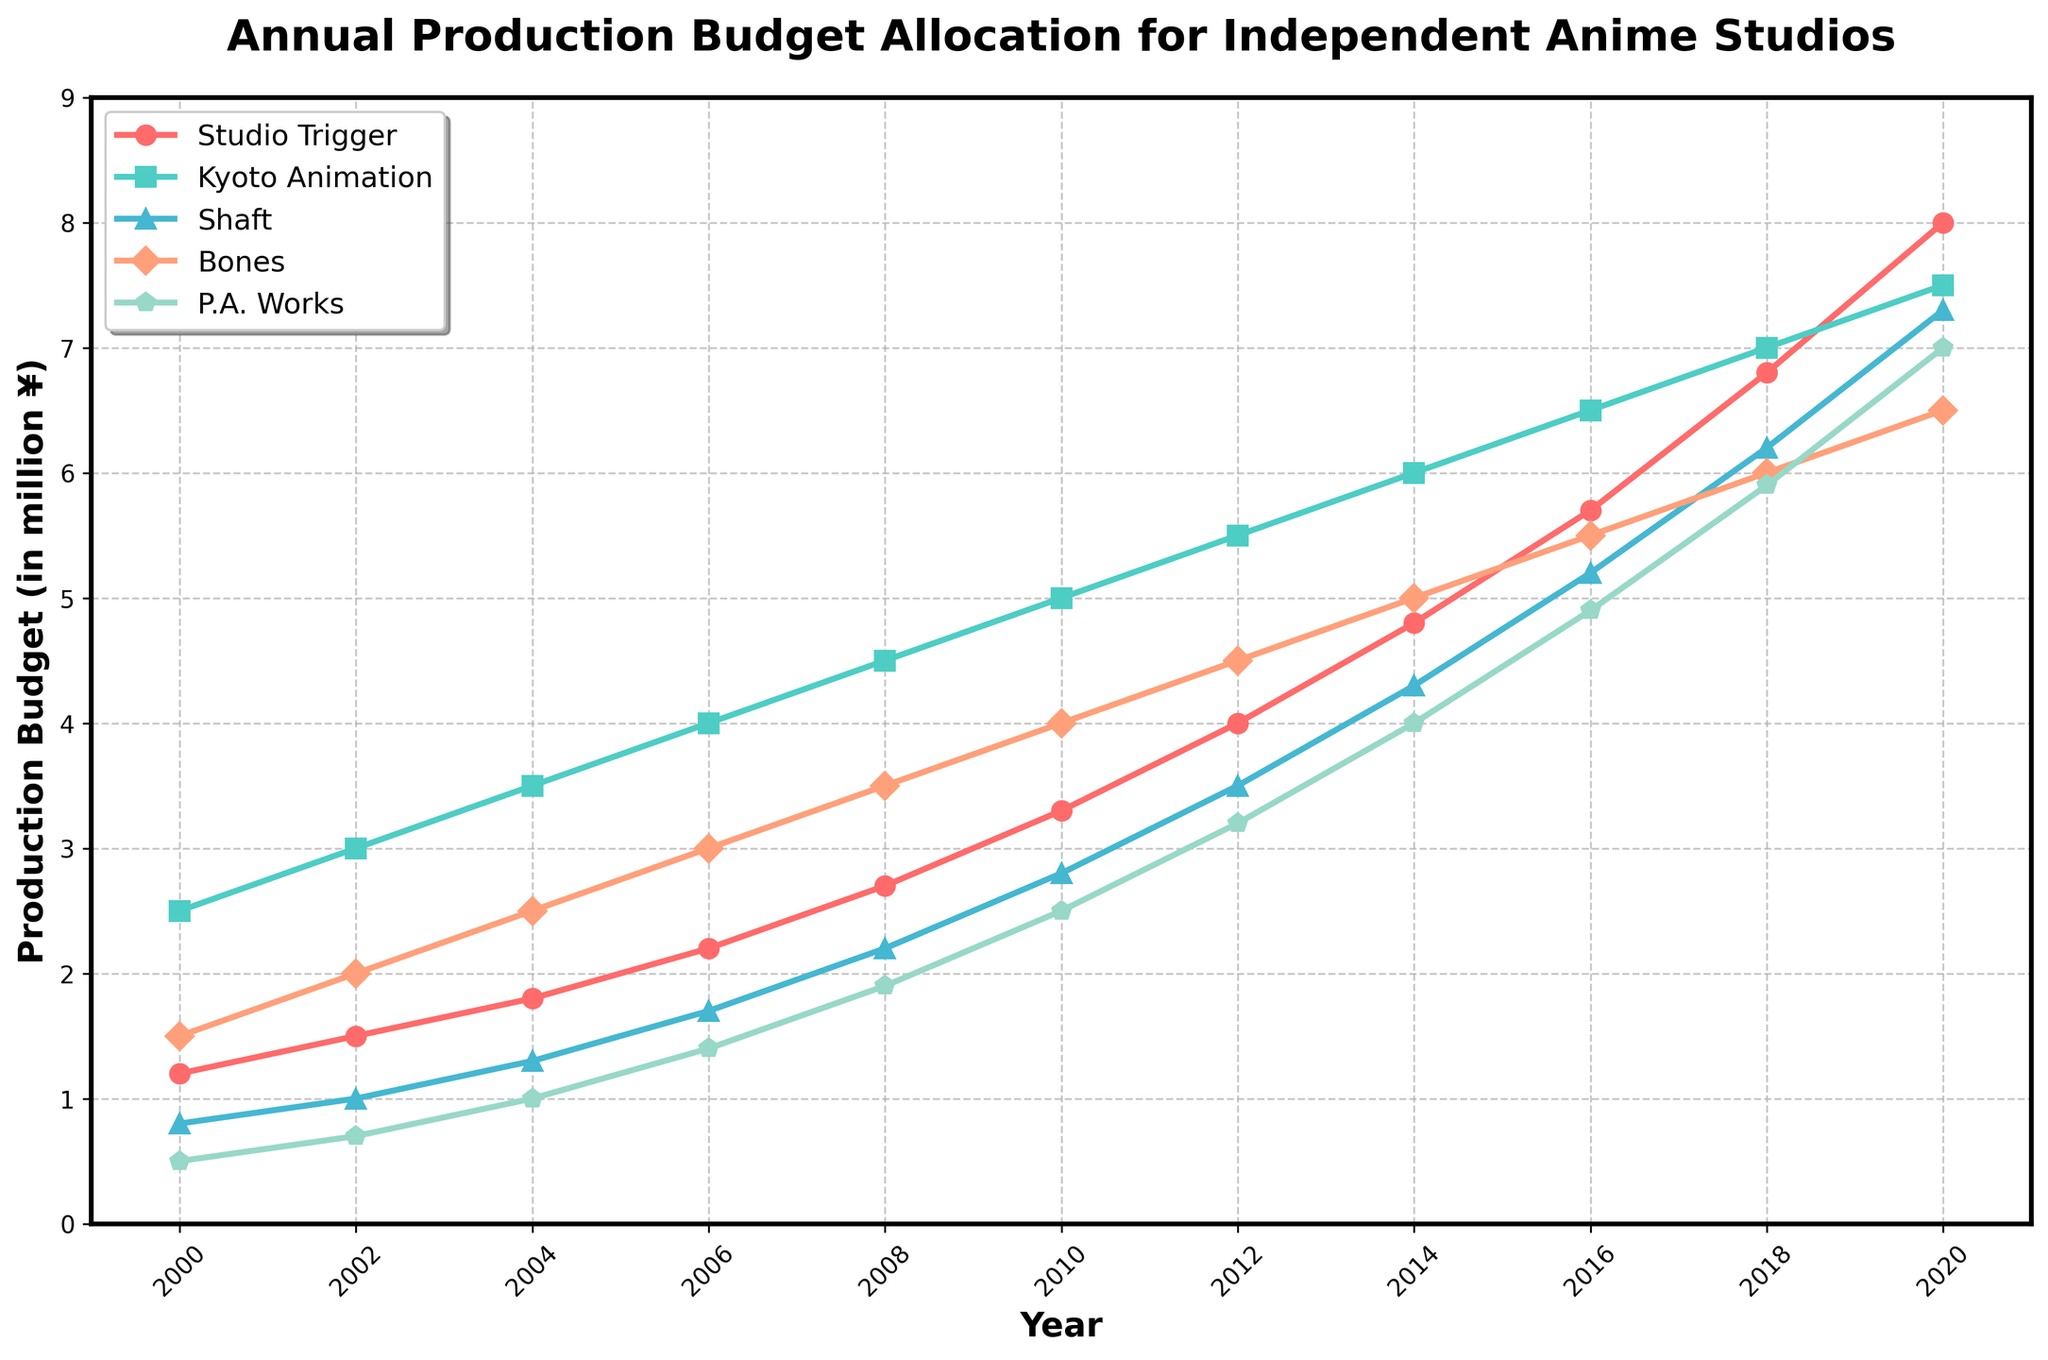What year did Studio Trigger's production budget first surpass 3 million ¥? Look at the line representing Studio Trigger and find the year when it first crosses the 3 million ¥ mark. This occurs in 2010.
Answer: 2010 Which studio had the highest production budget in 2020? Check the endpoints of each line representing different studios in 2020, and see which one is the highest. Kyoto Animation has the highest budget in 2020.
Answer: Kyoto Animation By how much did Kyoto Animation's production budget increase between 2004 and 2012? Subtract Kyoto Animation's budget in 2004 (3.5 million ¥) from its budget in 2012 (5.5 million ¥). The increase is 5.5 - 3.5 = 2 million ¥.
Answer: 2 million ¥ Which year saw the largest increase in Studio Shaft’s budget? Look for the year where the slope (rate of increase) of Studio Shaft's line is the steepest. The largest increase occurs between 2010 and 2012.
Answer: 2010-2012 Which two studios had the smallest difference in their budgets in 2016? Compare the vertical distance between all pairs of lines in 2016. Studio Bones and Studio Trigger had the smallest difference since they are closest to each other.
Answer: Studio Bones and Studio Trigger What was the average production budget for P.A. Works over the entire period? Sum P.A. Works’ budget for all the years provided and divide by the number of years (11). (0.5 + 0.7 + 1.0 + 1.4 + 1.9 + 2.5 + 3.2 + 4.0 + 4.9 + 5.9 + 7.0) / 11 = 32.0 / 11 ≈ 2.91 million ¥.
Answer: 2.91 million ¥ Did Studio Trigger's budget ever surpass Kyoto Animation’s budget in any year? Compare the lines for Studio Trigger and Kyoto Animation. Studio Trigger’s line never surpasses Kyoto Animation’s line at any point.
Answer: No By how much did P.A. Works' production budget increase from 2000 to 2020? Subtract P.A. Work’s budget in 2000 (0.5 million ¥) from its budget in 2020 (7.0 million ¥). The increase is 7.0 - 0.5 = 6.5 million ¥.
Answer: 6.5 million ¥ 